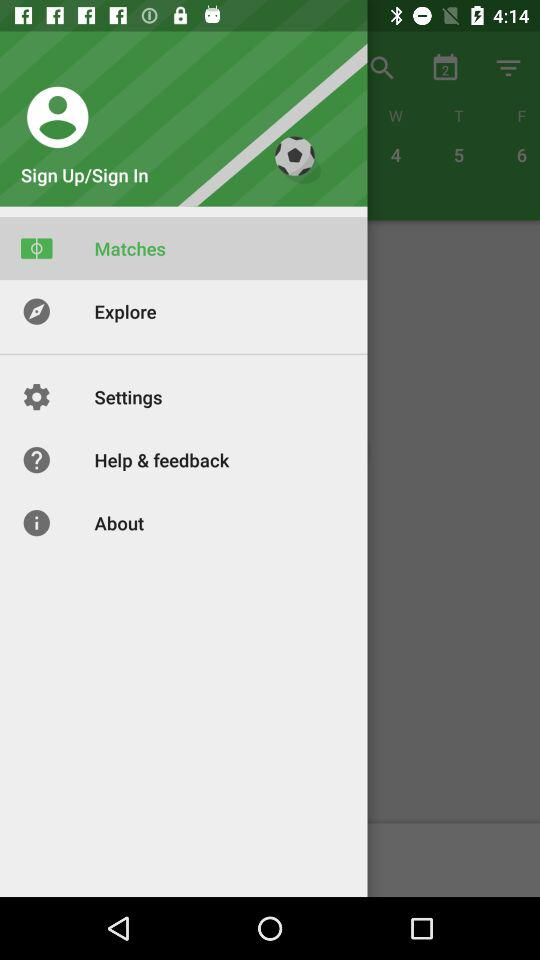How many days are displayed on the calendar?
Answer the question using a single word or phrase. 3 